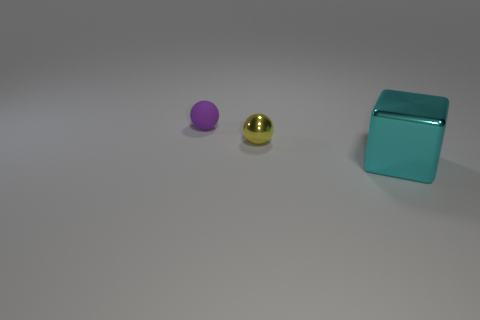Subtract all green cubes. Subtract all cyan cylinders. How many cubes are left? 1 Subtract all yellow balls. How many yellow cubes are left? 0 Add 3 objects. How many large cyans exist? 0 Subtract all gray cylinders. Subtract all tiny matte objects. How many objects are left? 2 Add 1 small yellow shiny balls. How many small yellow shiny balls are left? 2 Add 3 things. How many things exist? 6 Add 1 large brown spheres. How many objects exist? 4 Subtract all yellow spheres. How many spheres are left? 1 Subtract 1 yellow balls. How many objects are left? 2 Subtract all spheres. How many objects are left? 1 